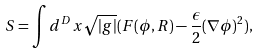<formula> <loc_0><loc_0><loc_500><loc_500>S = \int d ^ { D } x \sqrt { | g | } ( F ( \phi , R ) - \frac { \epsilon } { 2 } ( \nabla \phi ) ^ { 2 } ) ,</formula> 